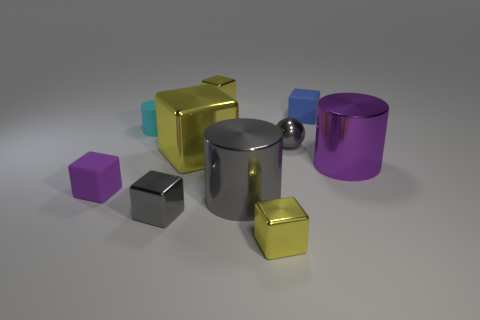Subtract all gray shiny cubes. How many cubes are left? 5 Subtract 5 blocks. How many blocks are left? 1 Subtract all gray blocks. How many blocks are left? 5 Subtract 0 brown blocks. How many objects are left? 10 Subtract all cylinders. How many objects are left? 7 Subtract all purple cubes. Subtract all yellow balls. How many cubes are left? 5 Subtract all green cubes. How many blue cylinders are left? 0 Subtract all big yellow matte things. Subtract all big metallic cubes. How many objects are left? 9 Add 4 blocks. How many blocks are left? 10 Add 5 big gray cylinders. How many big gray cylinders exist? 6 